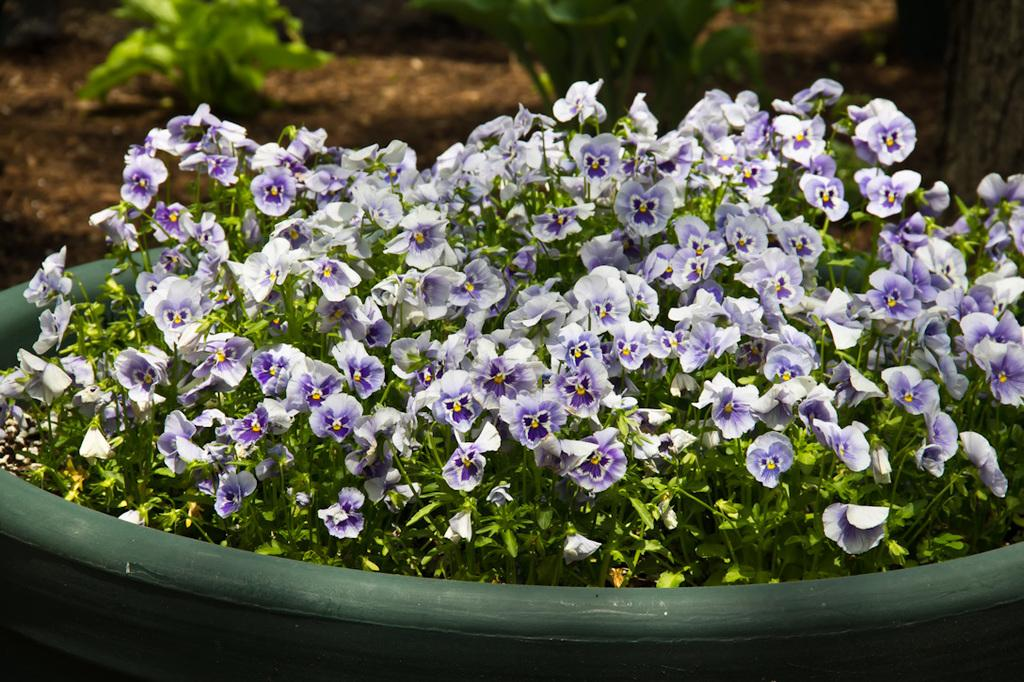What object can be seen in the image that holds plants? There is a flower pot in the image. What type of plants are present in the image? There is a group of flowers in the image. What can be seen in the background of the image? There are planets visible on the ground in the background of the image. What type of card is being used to play a game in the image? There is no card or game present in the image; it features a flower pot, a group of flowers, and planets visible on the ground. 